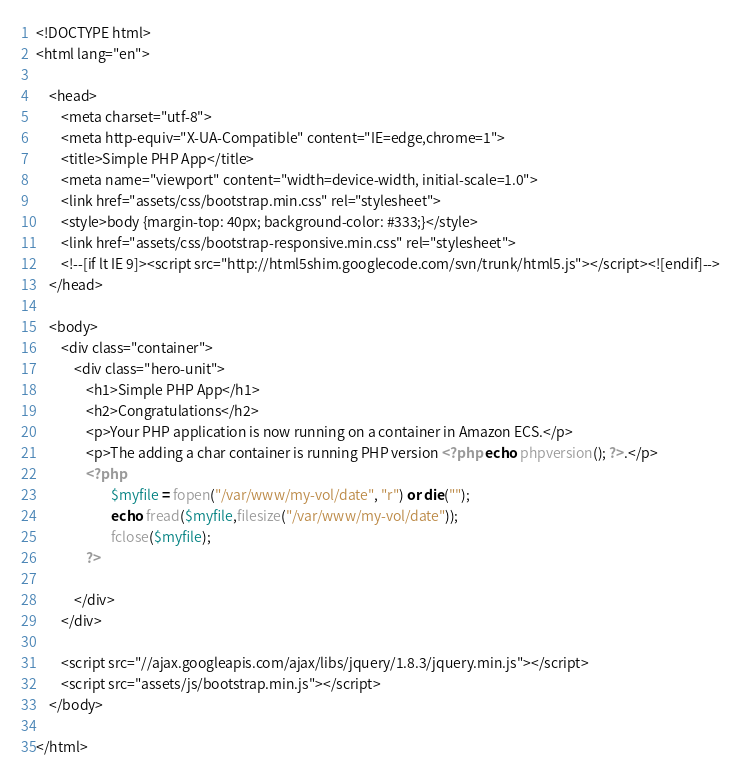<code> <loc_0><loc_0><loc_500><loc_500><_PHP_><!DOCTYPE html>
<html lang="en">

    <head>
        <meta charset="utf-8">
        <meta http-equiv="X-UA-Compatible" content="IE=edge,chrome=1">
        <title>Simple PHP App</title>
        <meta name="viewport" content="width=device-width, initial-scale=1.0">
        <link href="assets/css/bootstrap.min.css" rel="stylesheet">
        <style>body {margin-top: 40px; background-color: #333;}</style>
        <link href="assets/css/bootstrap-responsive.min.css" rel="stylesheet">
        <!--[if lt IE 9]><script src="http://html5shim.googlecode.com/svn/trunk/html5.js"></script><![endif]-->
    </head>

    <body>
        <div class="container">
            <div class="hero-unit">
                <h1>Simple PHP App</h1>
                <h2>Congratulations</h2>
                <p>Your PHP application is now running on a container in Amazon ECS.</p>
                <p>The adding a char container is running PHP version <?php echo phpversion(); ?>.</p>
                <?php
                        $myfile = fopen("/var/www/my-vol/date", "r") or die("");
                        echo fread($myfile,filesize("/var/www/my-vol/date"));
                        fclose($myfile);
                ?>

            </div>
        </div>

        <script src="//ajax.googleapis.com/ajax/libs/jquery/1.8.3/jquery.min.js"></script>
        <script src="assets/js/bootstrap.min.js"></script>
    </body>

</html>
</code> 